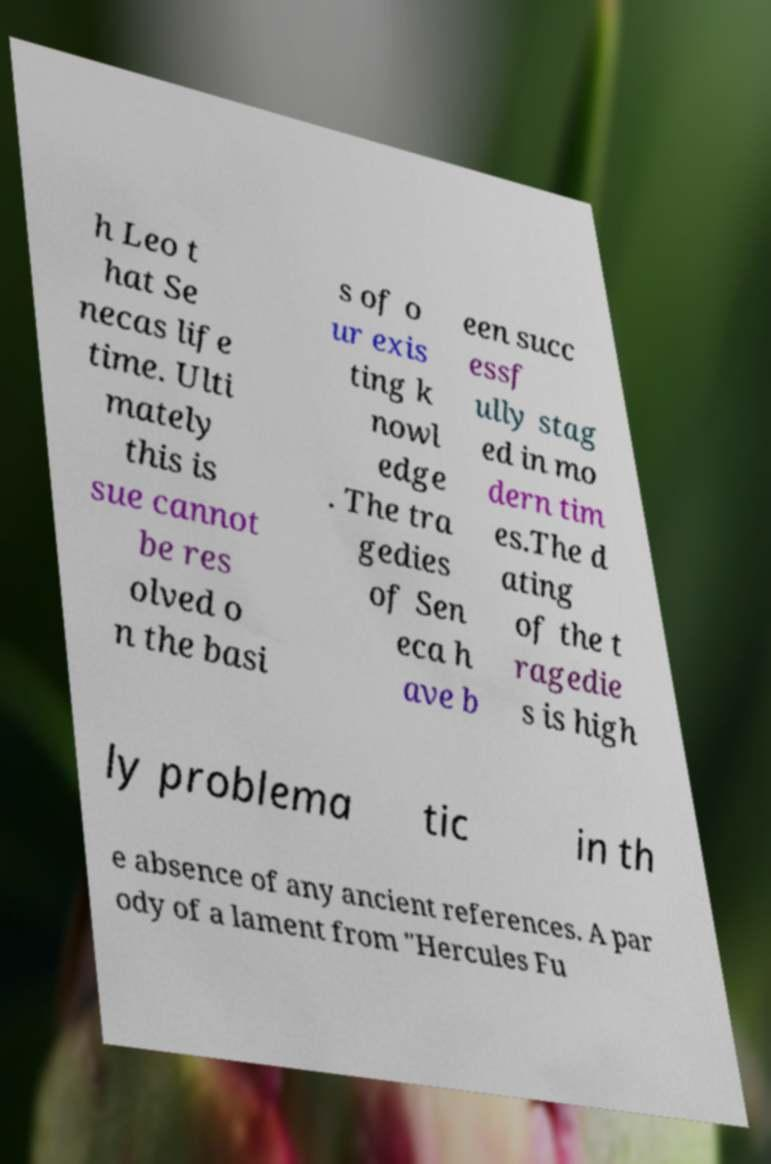Could you extract and type out the text from this image? h Leo t hat Se necas life time. Ulti mately this is sue cannot be res olved o n the basi s of o ur exis ting k nowl edge . The tra gedies of Sen eca h ave b een succ essf ully stag ed in mo dern tim es.The d ating of the t ragedie s is high ly problema tic in th e absence of any ancient references. A par ody of a lament from "Hercules Fu 